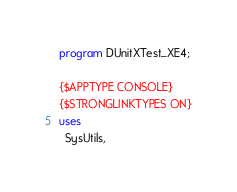Convert code to text. <code><loc_0><loc_0><loc_500><loc_500><_Pascal_>program DUnitXTest_XE4;

{$APPTYPE CONSOLE}
{$STRONGLINKTYPES ON}
uses
  SysUtils,</code> 